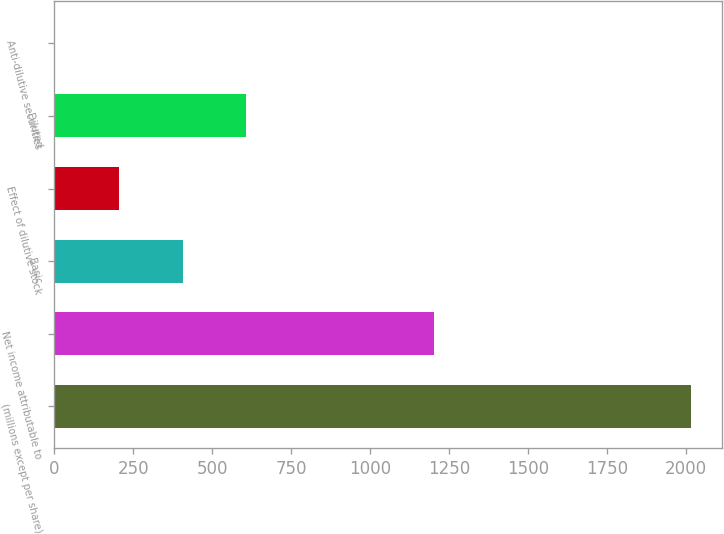Convert chart. <chart><loc_0><loc_0><loc_500><loc_500><bar_chart><fcel>(millions except per share)<fcel>Net income attributable to<fcel>Basic<fcel>Effect of dilutive stock<fcel>Diluted<fcel>Anti-dilutive securities<nl><fcel>2014<fcel>1202.8<fcel>405.52<fcel>204.46<fcel>606.58<fcel>3.4<nl></chart> 